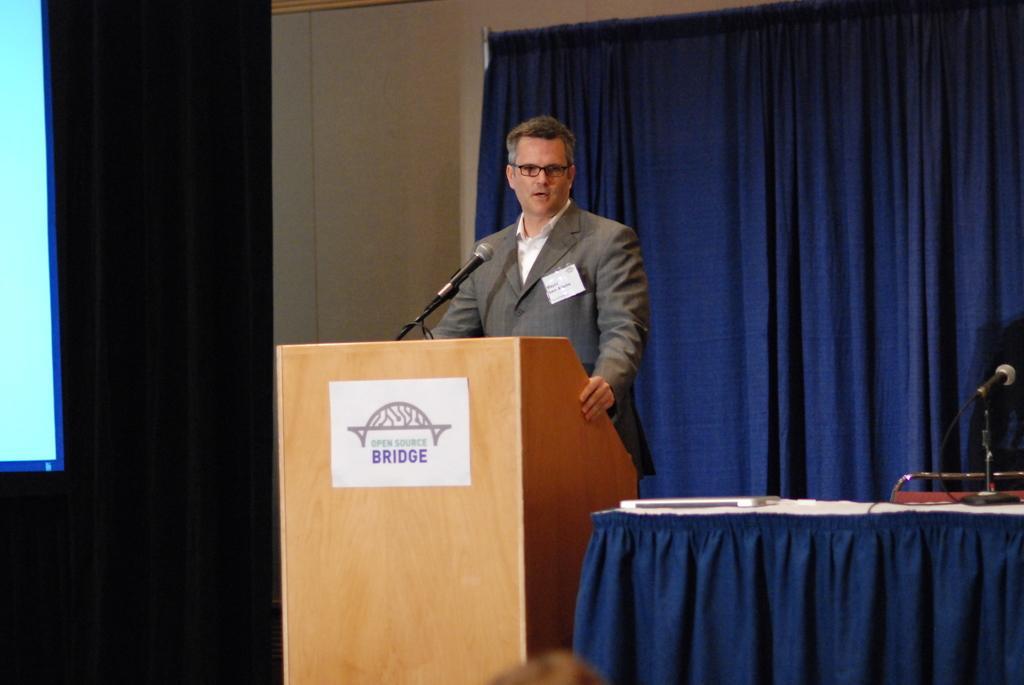In one or two sentences, can you explain what this image depicts? In this image, we can see a person. We can see the podium and a few microphones. We can also see a table covered with a cloth and some objects are placed on it. We can also see some curtains. We can see the poster with some image and text. We can also see a projector screen on the left. We can see an object at the bottom. 